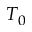Convert formula to latex. <formula><loc_0><loc_0><loc_500><loc_500>T _ { 0 }</formula> 